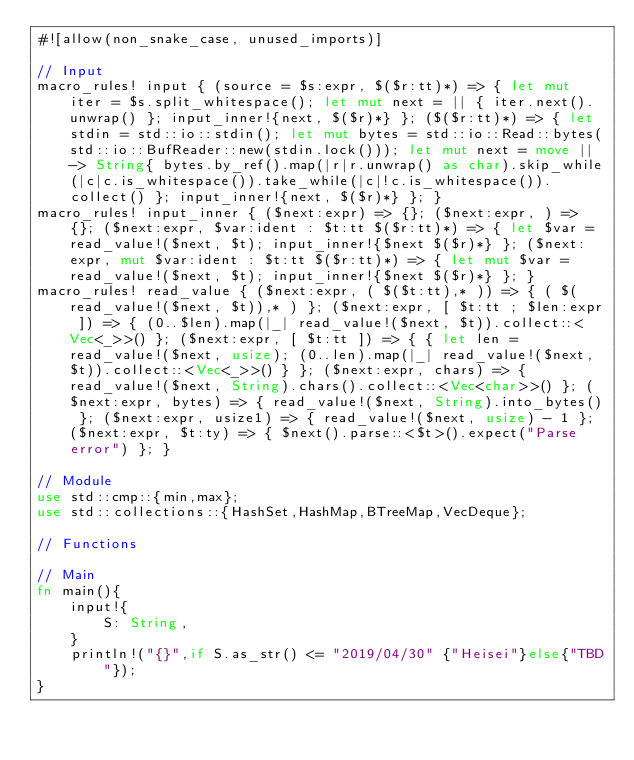Convert code to text. <code><loc_0><loc_0><loc_500><loc_500><_Rust_>#![allow(non_snake_case, unused_imports)]

// Input
macro_rules! input { (source = $s:expr, $($r:tt)*) => { let mut iter = $s.split_whitespace(); let mut next = || { iter.next().unwrap() }; input_inner!{next, $($r)*} }; ($($r:tt)*) => { let stdin = std::io::stdin(); let mut bytes = std::io::Read::bytes(std::io::BufReader::new(stdin.lock())); let mut next = move || -> String{ bytes.by_ref().map(|r|r.unwrap() as char).skip_while(|c|c.is_whitespace()).take_while(|c|!c.is_whitespace()).collect() }; input_inner!{next, $($r)*} }; }
macro_rules! input_inner { ($next:expr) => {}; ($next:expr, ) => {}; ($next:expr, $var:ident : $t:tt $($r:tt)*) => { let $var = read_value!($next, $t); input_inner!{$next $($r)*} }; ($next:expr, mut $var:ident : $t:tt $($r:tt)*) => { let mut $var = read_value!($next, $t); input_inner!{$next $($r)*} }; }
macro_rules! read_value { ($next:expr, ( $($t:tt),* )) => { ( $(read_value!($next, $t)),* ) }; ($next:expr, [ $t:tt ; $len:expr ]) => { (0..$len).map(|_| read_value!($next, $t)).collect::<Vec<_>>() }; ($next:expr, [ $t:tt ]) => { { let len = read_value!($next, usize); (0..len).map(|_| read_value!($next, $t)).collect::<Vec<_>>() } }; ($next:expr, chars) => { read_value!($next, String).chars().collect::<Vec<char>>() }; ($next:expr, bytes) => { read_value!($next, String).into_bytes() }; ($next:expr, usize1) => { read_value!($next, usize) - 1 }; ($next:expr, $t:ty) => { $next().parse::<$t>().expect("Parse error") }; }

// Module
use std::cmp::{min,max};
use std::collections::{HashSet,HashMap,BTreeMap,VecDeque};

// Functions

// Main
fn main(){
    input!{
        S: String,
    }
    println!("{}",if S.as_str() <= "2019/04/30" {"Heisei"}else{"TBD"});
}</code> 